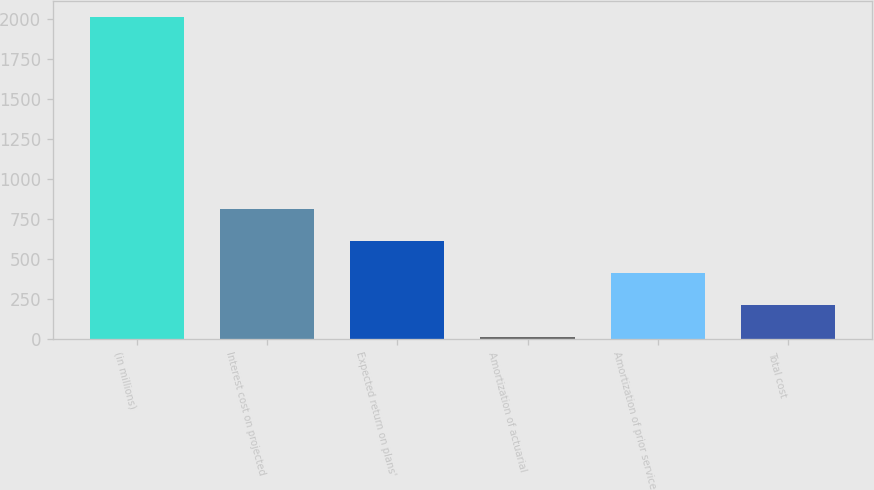Convert chart to OTSL. <chart><loc_0><loc_0><loc_500><loc_500><bar_chart><fcel>(in millions)<fcel>Interest cost on projected<fcel>Expected return on plans'<fcel>Amortization of actuarial<fcel>Amortization of prior service<fcel>Total cost<nl><fcel>2014<fcel>815.2<fcel>615.4<fcel>16<fcel>415.6<fcel>215.8<nl></chart> 